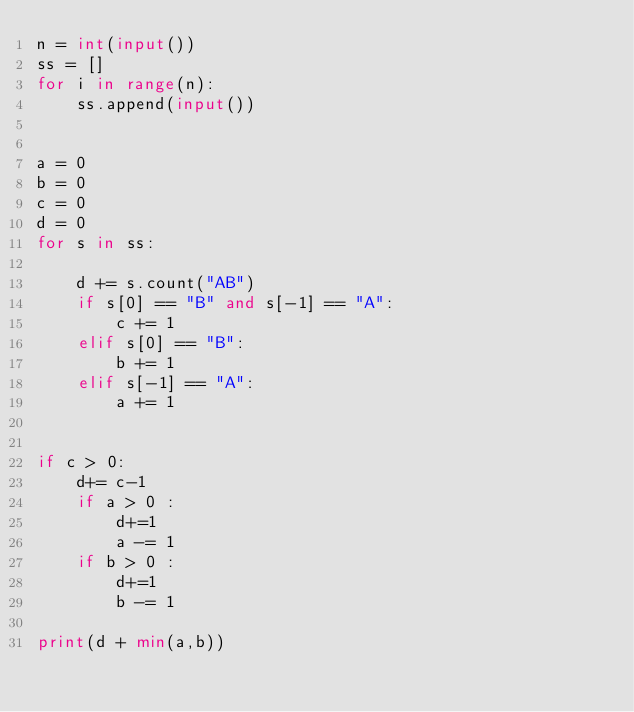<code> <loc_0><loc_0><loc_500><loc_500><_Python_>n = int(input())
ss = []
for i in range(n):
    ss.append(input())


a = 0
b = 0
c = 0
d = 0
for s in ss:

    d += s.count("AB")
    if s[0] == "B" and s[-1] == "A":
        c += 1
    elif s[0] == "B":
        b += 1
    elif s[-1] == "A":
        a += 1


if c > 0:
    d+= c-1
    if a > 0 :
        d+=1
        a -= 1
    if b > 0 :
        d+=1
        b -= 1

print(d + min(a,b))</code> 